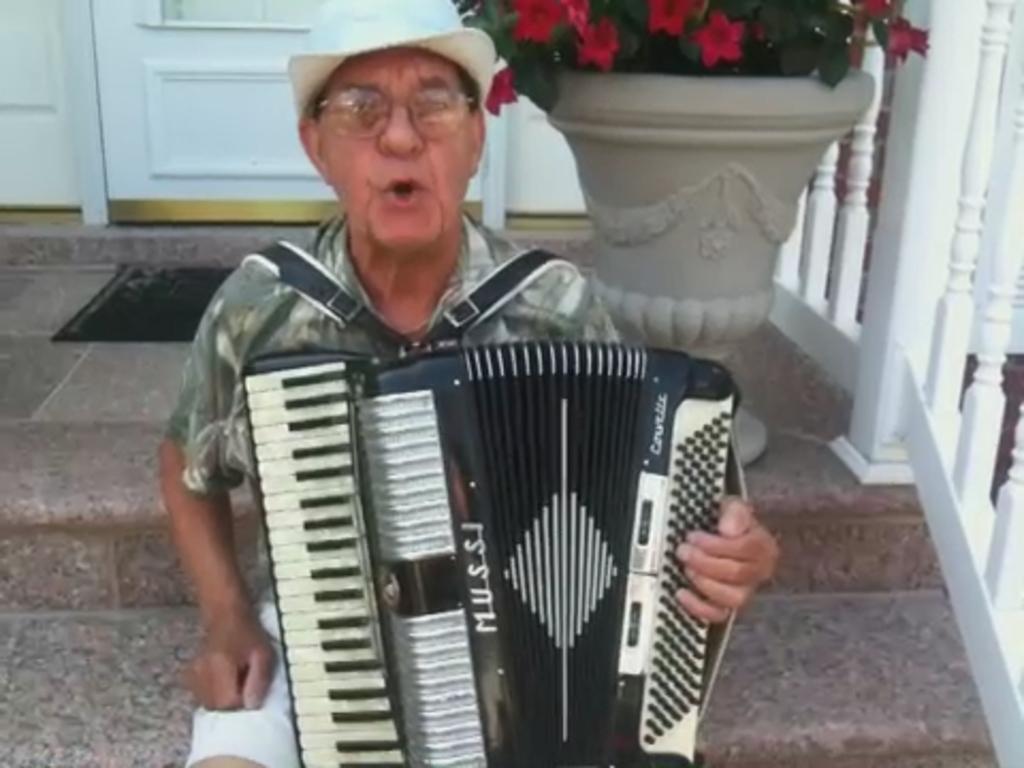Describe this image in one or two sentences. In the image we can see a man sitting, wearing clothes, spectacles, hat and there is a musical instrument on his lap. Here we can see flower pot, fence, stairs and the door.  